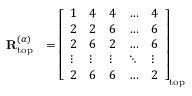<formula> <loc_0><loc_0><loc_500><loc_500>\begin{array} { r l } { R _ { t o p } ^ { ( \alpha ) } } & { = \left [ \begin{array} { l l l l l } { 1 } & { 4 } & { 4 } & { \dots } & { 4 } \\ { 2 } & { 2 } & { 6 } & { \dots } & { 6 } \\ { 2 } & { 6 } & { 2 } & { \dots } & { 6 } \\ { \vdots } & { \vdots } & { \vdots } & { \ddots } & { \vdots } \\ { 2 } & { 6 } & { 6 } & { \dots } & { 2 } \end{array} \right ] _ { t o p } } \end{array}</formula> 